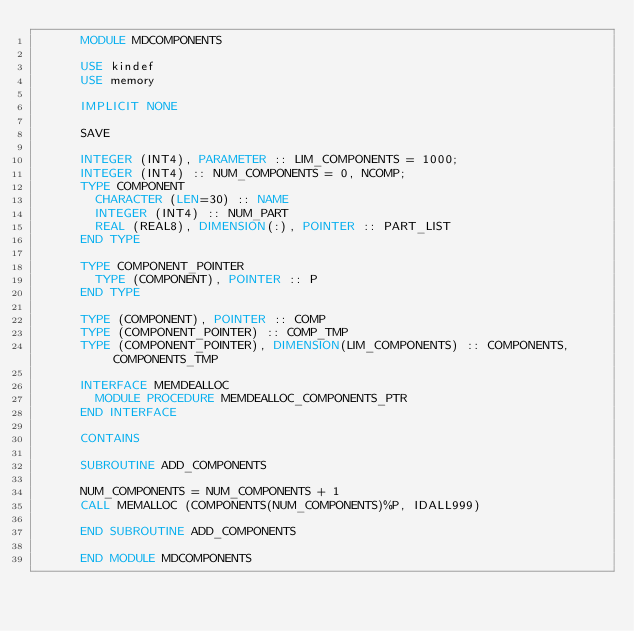<code> <loc_0><loc_0><loc_500><loc_500><_FORTRAN_>      MODULE MDCOMPONENTS
      
      USE kindef
      USE memory

      IMPLICIT NONE

      SAVE

      INTEGER (INT4), PARAMETER :: LIM_COMPONENTS = 1000;
      INTEGER (INT4) :: NUM_COMPONENTS = 0, NCOMP;
      TYPE COMPONENT
        CHARACTER (LEN=30) :: NAME
        INTEGER (INT4) :: NUM_PART
        REAL (REAL8), DIMENSION(:), POINTER :: PART_LIST
      END TYPE

      TYPE COMPONENT_POINTER 
        TYPE (COMPONENT), POINTER :: P
      END TYPE

      TYPE (COMPONENT), POINTER :: COMP
      TYPE (COMPONENT_POINTER) :: COMP_TMP
      TYPE (COMPONENT_POINTER), DIMENSION(LIM_COMPONENTS) :: COMPONENTS, COMPONENTS_TMP

      INTERFACE MEMDEALLOC
        MODULE PROCEDURE MEMDEALLOC_COMPONENTS_PTR
      END INTERFACE
  
      CONTAINS

      SUBROUTINE ADD_COMPONENTS

      NUM_COMPONENTS = NUM_COMPONENTS + 1
      CALL MEMALLOC (COMPONENTS(NUM_COMPONENTS)%P, IDALL999)

      END SUBROUTINE ADD_COMPONENTS

      END MODULE MDCOMPONENTS
</code> 